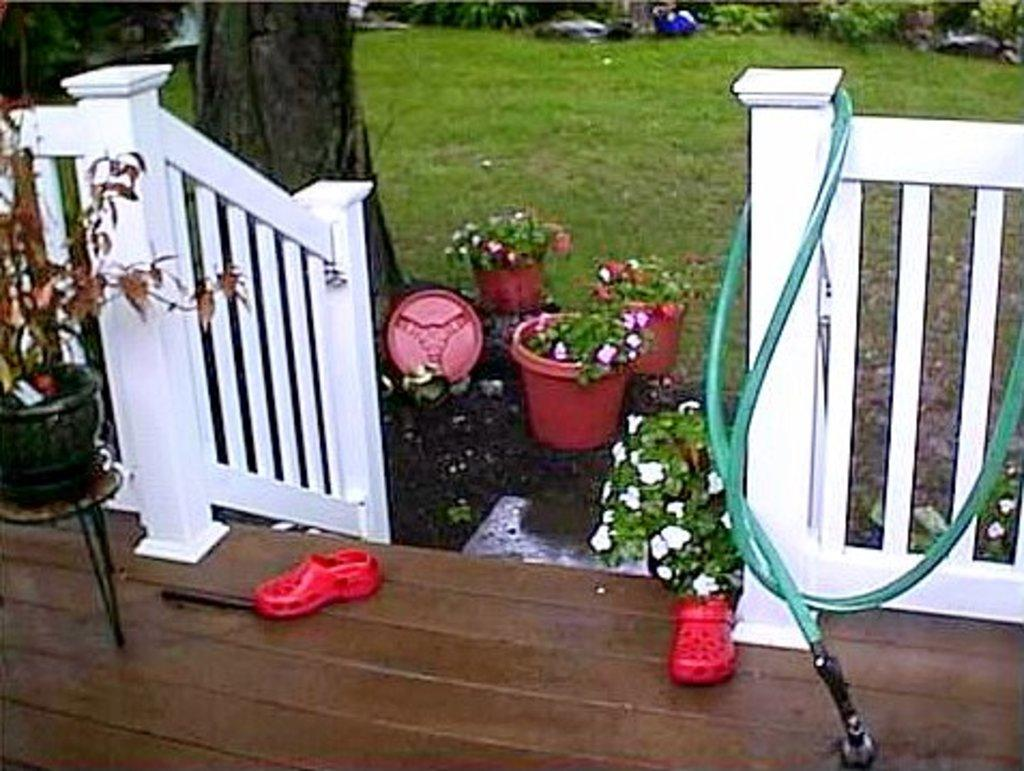What type of plants can be seen in the image? There are plants in pots and plants on the ground in the image. What can be seen near the plants on the ground? Grass is visible on the ground in the image. What type of material is present on the trees in the image? Tree bark is present in the image. What object related to water is visible in the image? There is a water pipe in the image. What type of footwear can be seen in the image? Footwear is visible in the image. What type of hospital is visible in the background of the image? There is no hospital present in the image; it features plants, footwear, and a water pipe. 